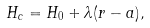<formula> <loc_0><loc_0><loc_500><loc_500>H _ { c } = H _ { 0 } + \lambda ( r - a ) ,</formula> 